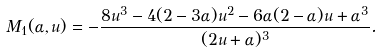Convert formula to latex. <formula><loc_0><loc_0><loc_500><loc_500>M _ { 1 } ( \alpha , u ) = - \frac { 8 u ^ { 3 } - 4 ( 2 - 3 \alpha ) u ^ { 2 } - 6 \alpha ( 2 - \alpha ) u + \alpha ^ { 3 } } { ( 2 u + \alpha ) ^ { 3 } } .</formula> 